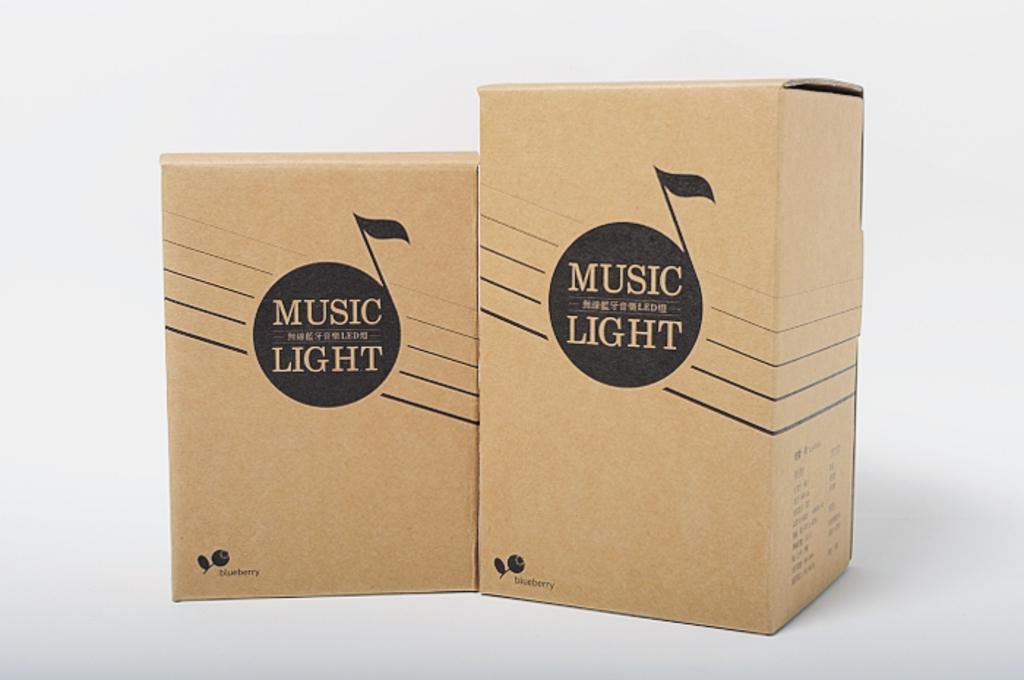Describe this image in one or two sentences. In this image I can see two cardboard boxes which are black and brown in color on the white colored surface. I can see the white colored background. 